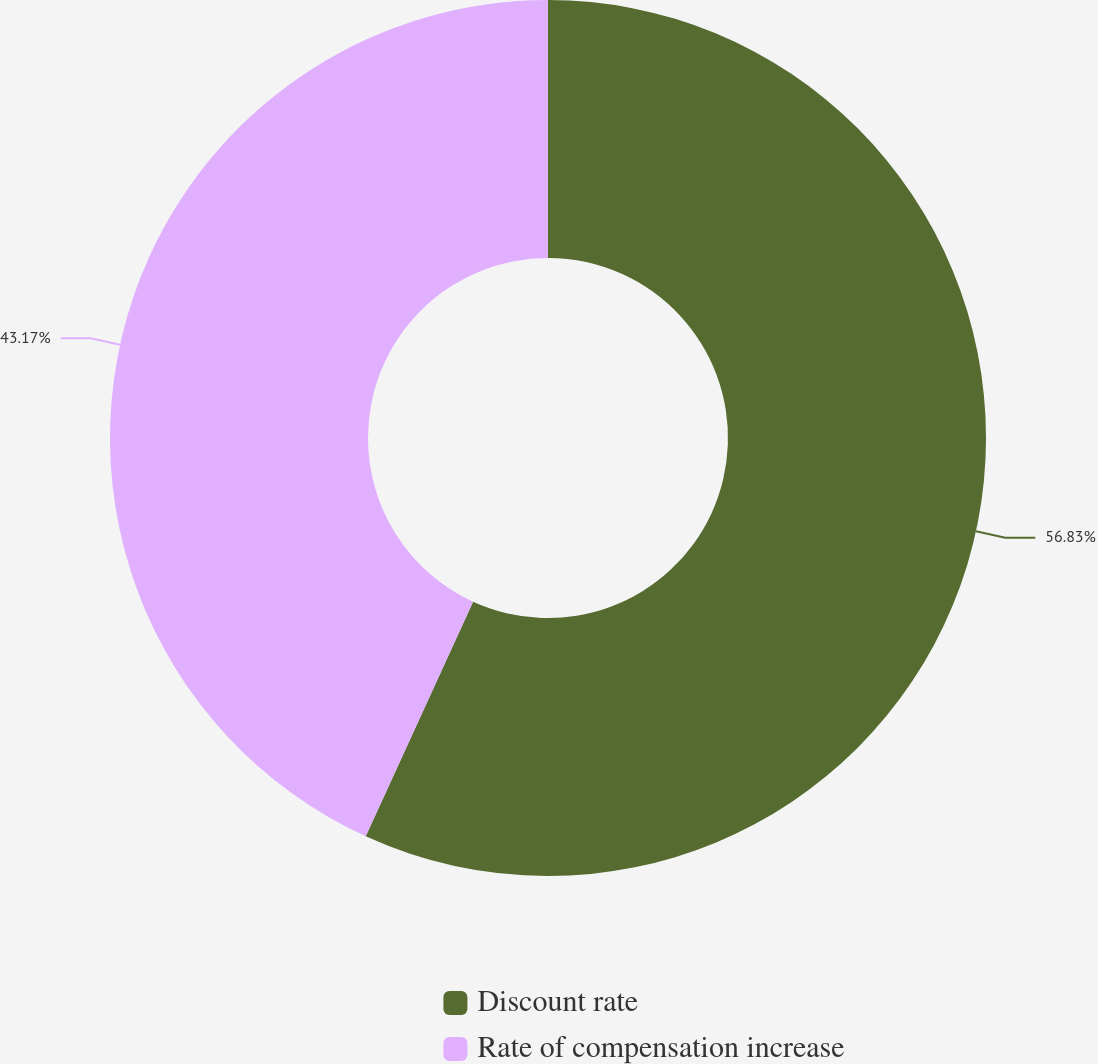Convert chart. <chart><loc_0><loc_0><loc_500><loc_500><pie_chart><fcel>Discount rate<fcel>Rate of compensation increase<nl><fcel>56.83%<fcel>43.17%<nl></chart> 